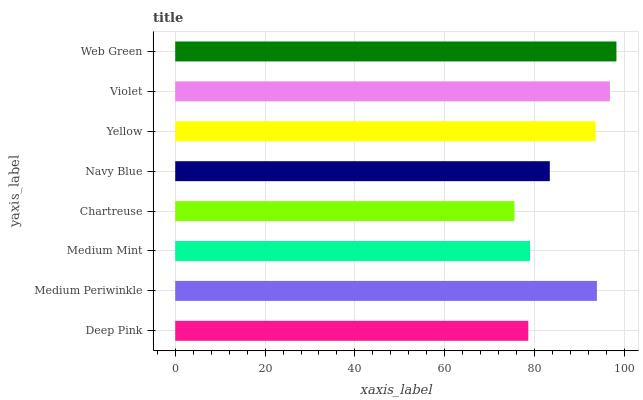Is Chartreuse the minimum?
Answer yes or no. Yes. Is Web Green the maximum?
Answer yes or no. Yes. Is Medium Periwinkle the minimum?
Answer yes or no. No. Is Medium Periwinkle the maximum?
Answer yes or no. No. Is Medium Periwinkle greater than Deep Pink?
Answer yes or no. Yes. Is Deep Pink less than Medium Periwinkle?
Answer yes or no. Yes. Is Deep Pink greater than Medium Periwinkle?
Answer yes or no. No. Is Medium Periwinkle less than Deep Pink?
Answer yes or no. No. Is Yellow the high median?
Answer yes or no. Yes. Is Navy Blue the low median?
Answer yes or no. Yes. Is Violet the high median?
Answer yes or no. No. Is Chartreuse the low median?
Answer yes or no. No. 